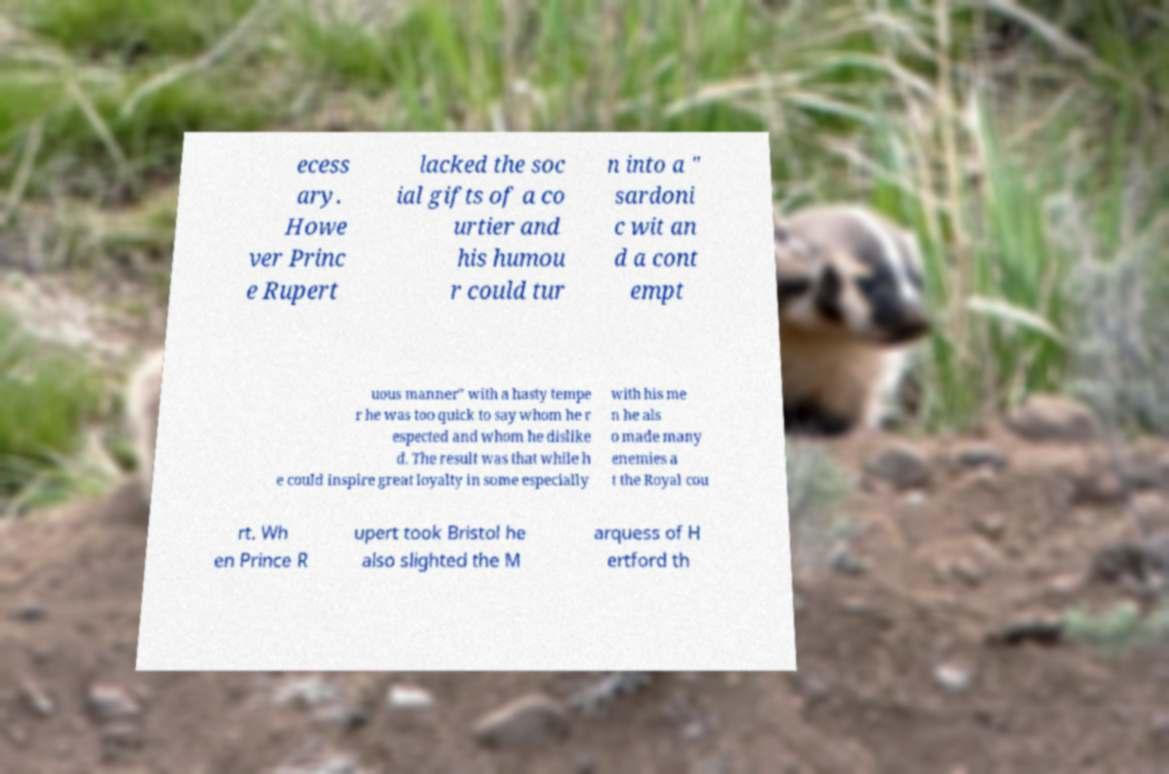Could you extract and type out the text from this image? ecess ary. Howe ver Princ e Rupert lacked the soc ial gifts of a co urtier and his humou r could tur n into a " sardoni c wit an d a cont empt uous manner" with a hasty tempe r he was too quick to say whom he r espected and whom he dislike d. The result was that while h e could inspire great loyalty in some especially with his me n he als o made many enemies a t the Royal cou rt. Wh en Prince R upert took Bristol he also slighted the M arquess of H ertford th 